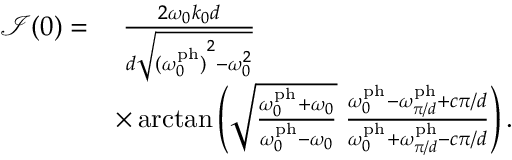<formula> <loc_0><loc_0><loc_500><loc_500>\begin{array} { r l } { \mathcal { I } ( 0 ) = } & { \, \frac { 2 \omega _ { 0 } k _ { 0 } d } { d \sqrt { { ( \omega _ { 0 } ^ { p h } ) } ^ { 2 } - \omega _ { 0 } ^ { 2 } } } } \\ & { \times \arctan \left ( \sqrt { \frac { \omega _ { 0 } ^ { p h } + \omega _ { 0 } } { \omega _ { 0 } ^ { p h } - \omega _ { 0 } } } \, \frac { \omega _ { 0 } ^ { p h } - \omega _ { \pi / d } ^ { p h } + c \pi / d } { \omega _ { 0 } ^ { p h } + \omega _ { \pi / d } ^ { p h } - c \pi / d } \right ) . } \end{array}</formula> 